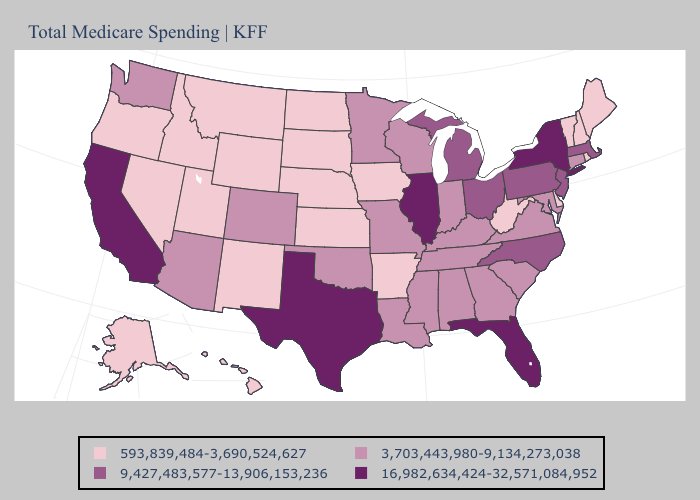Among the states that border New Jersey , which have the lowest value?
Give a very brief answer. Delaware. Which states have the lowest value in the Northeast?
Concise answer only. Maine, New Hampshire, Rhode Island, Vermont. Does the map have missing data?
Give a very brief answer. No. Which states hav the highest value in the Northeast?
Give a very brief answer. New York. Name the states that have a value in the range 16,982,634,424-32,571,084,952?
Quick response, please. California, Florida, Illinois, New York, Texas. Does New Jersey have the same value as Louisiana?
Write a very short answer. No. Name the states that have a value in the range 593,839,484-3,690,524,627?
Be succinct. Alaska, Arkansas, Delaware, Hawaii, Idaho, Iowa, Kansas, Maine, Montana, Nebraska, Nevada, New Hampshire, New Mexico, North Dakota, Oregon, Rhode Island, South Dakota, Utah, Vermont, West Virginia, Wyoming. Name the states that have a value in the range 3,703,443,980-9,134,273,038?
Be succinct. Alabama, Arizona, Colorado, Connecticut, Georgia, Indiana, Kentucky, Louisiana, Maryland, Minnesota, Mississippi, Missouri, Oklahoma, South Carolina, Tennessee, Virginia, Washington, Wisconsin. What is the value of Wisconsin?
Short answer required. 3,703,443,980-9,134,273,038. Does Illinois have the highest value in the MidWest?
Concise answer only. Yes. Name the states that have a value in the range 593,839,484-3,690,524,627?
Give a very brief answer. Alaska, Arkansas, Delaware, Hawaii, Idaho, Iowa, Kansas, Maine, Montana, Nebraska, Nevada, New Hampshire, New Mexico, North Dakota, Oregon, Rhode Island, South Dakota, Utah, Vermont, West Virginia, Wyoming. Does California have the highest value in the USA?
Write a very short answer. Yes. What is the value of Arizona?
Concise answer only. 3,703,443,980-9,134,273,038. Which states have the highest value in the USA?
Concise answer only. California, Florida, Illinois, New York, Texas. Does Tennessee have a higher value than Alaska?
Concise answer only. Yes. 